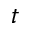<formula> <loc_0><loc_0><loc_500><loc_500>t</formula> 